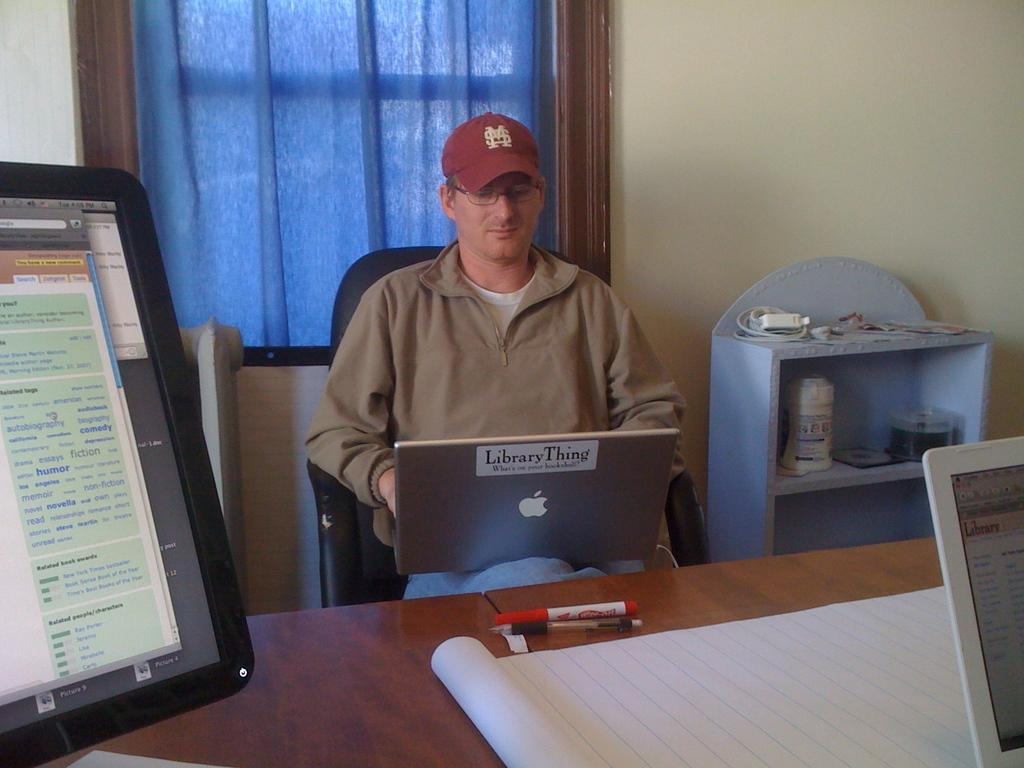Provide a one-sentence caption for the provided image. A man in a red hat and park sits with a silver apple laptop on his lap. 